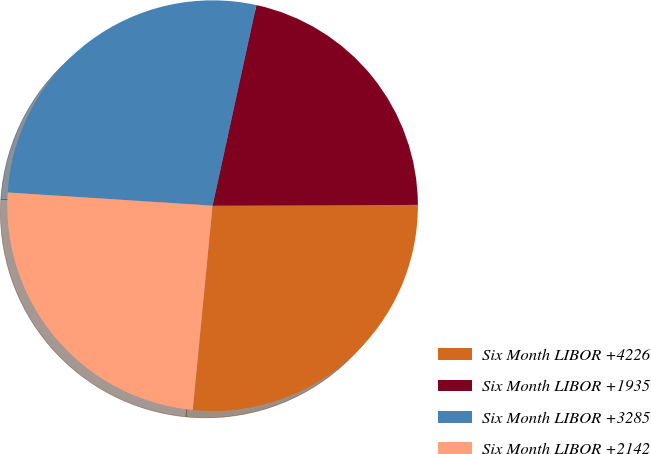Convert chart to OTSL. <chart><loc_0><loc_0><loc_500><loc_500><pie_chart><fcel>Six Month LIBOR +4226<fcel>Six Month LIBOR +1935<fcel>Six Month LIBOR +3285<fcel>Six Month LIBOR +2142<nl><fcel>26.6%<fcel>21.52%<fcel>27.4%<fcel>24.48%<nl></chart> 